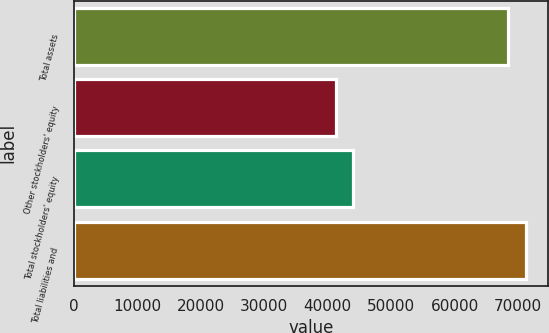Convert chart. <chart><loc_0><loc_0><loc_500><loc_500><bar_chart><fcel>Total assets<fcel>Other stockholders' equity<fcel>Total stockholders' equity<fcel>Total liabilities and<nl><fcel>68492<fcel>41306<fcel>44024.6<fcel>71210.6<nl></chart> 